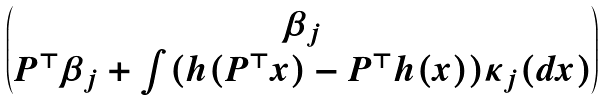Convert formula to latex. <formula><loc_0><loc_0><loc_500><loc_500>\begin{pmatrix} \beta _ { j } \\ P ^ { \top } \beta _ { j } + \int ( h ( P ^ { \top } x ) - P ^ { \top } h ( x ) ) \kappa _ { j } ( d x ) \end{pmatrix}</formula> 